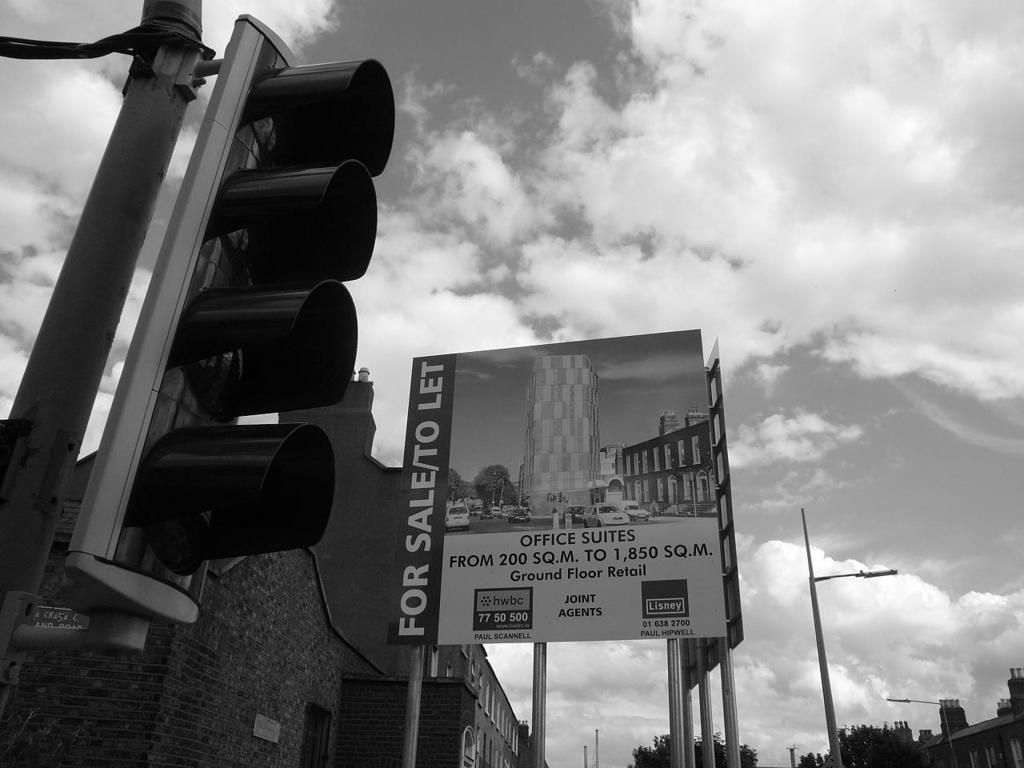<image>
Summarize the visual content of the image. A sign shows office suites which are for sale and to let. 